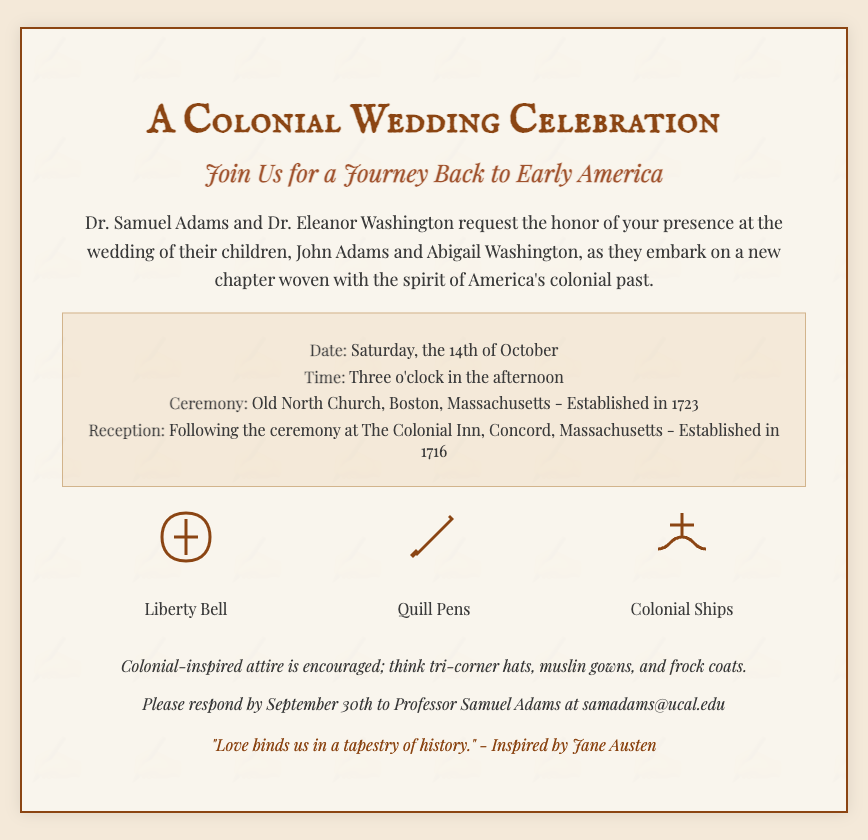What is the date of the wedding? The date of the wedding is specifically mentioned in the details section of the invitation.
Answer: Saturday, the 14th of October Who are the children of Dr. Samuel Adams and Dr. Eleanor Washington? The invitation mentions the names of their children who are getting married.
Answer: John Adams and Abigail Washington Where is the ceremony taking place? The ceremony location is explicitly stated in the invitation details.
Answer: Old North Church, Boston, Massachusetts What style of attire is encouraged for the guests? The additional notes section gives a clear description of the desired attire for the celebration.
Answer: Colonial-inspired attire What year was the Old North Church established? The establishment year for the Old North Church is provided in the ceremony details.
Answer: 1723 What is the quote attributed to in the invitation? The quote provided at the bottom of the invitation indicates its origin.
Answer: Inspired by Jane Austen What is the email address for RSVP? The invitation specifically lists the email address for responding to the invitation.
Answer: samadams@ucal.edu What illustrations are included in the invitation? The details of the illustrations can be found in the visual sections of the invitation.
Answer: Liberty Bell, Quill Pens, Colonial Ships What is the time of the wedding ceremony? The time of the ceremony is mentioned in the details section of the invitation.
Answer: Three o'clock in the afternoon 